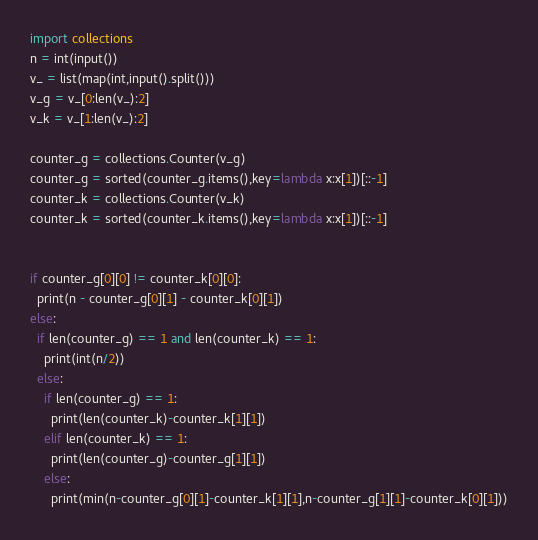<code> <loc_0><loc_0><loc_500><loc_500><_Python_>import collections
n = int(input())
v_ = list(map(int,input().split()))
v_g = v_[0:len(v_):2]
v_k = v_[1:len(v_):2]

counter_g = collections.Counter(v_g)
counter_g = sorted(counter_g.items(),key=lambda x:x[1])[::-1]
counter_k = collections.Counter(v_k)
counter_k = sorted(counter_k.items(),key=lambda x:x[1])[::-1]


if counter_g[0][0] != counter_k[0][0]:
  print(n - counter_g[0][1] - counter_k[0][1])
else:
  if len(counter_g) == 1 and len(counter_k) == 1:
    print(int(n/2))
  else:
    if len(counter_g) == 1:
      print(len(counter_k)-counter_k[1][1])
    elif len(counter_k) == 1:
      print(len(counter_g)-counter_g[1][1])
    else:
      print(min(n-counter_g[0][1]-counter_k[1][1],n-counter_g[1][1]-counter_k[0][1]))


</code> 